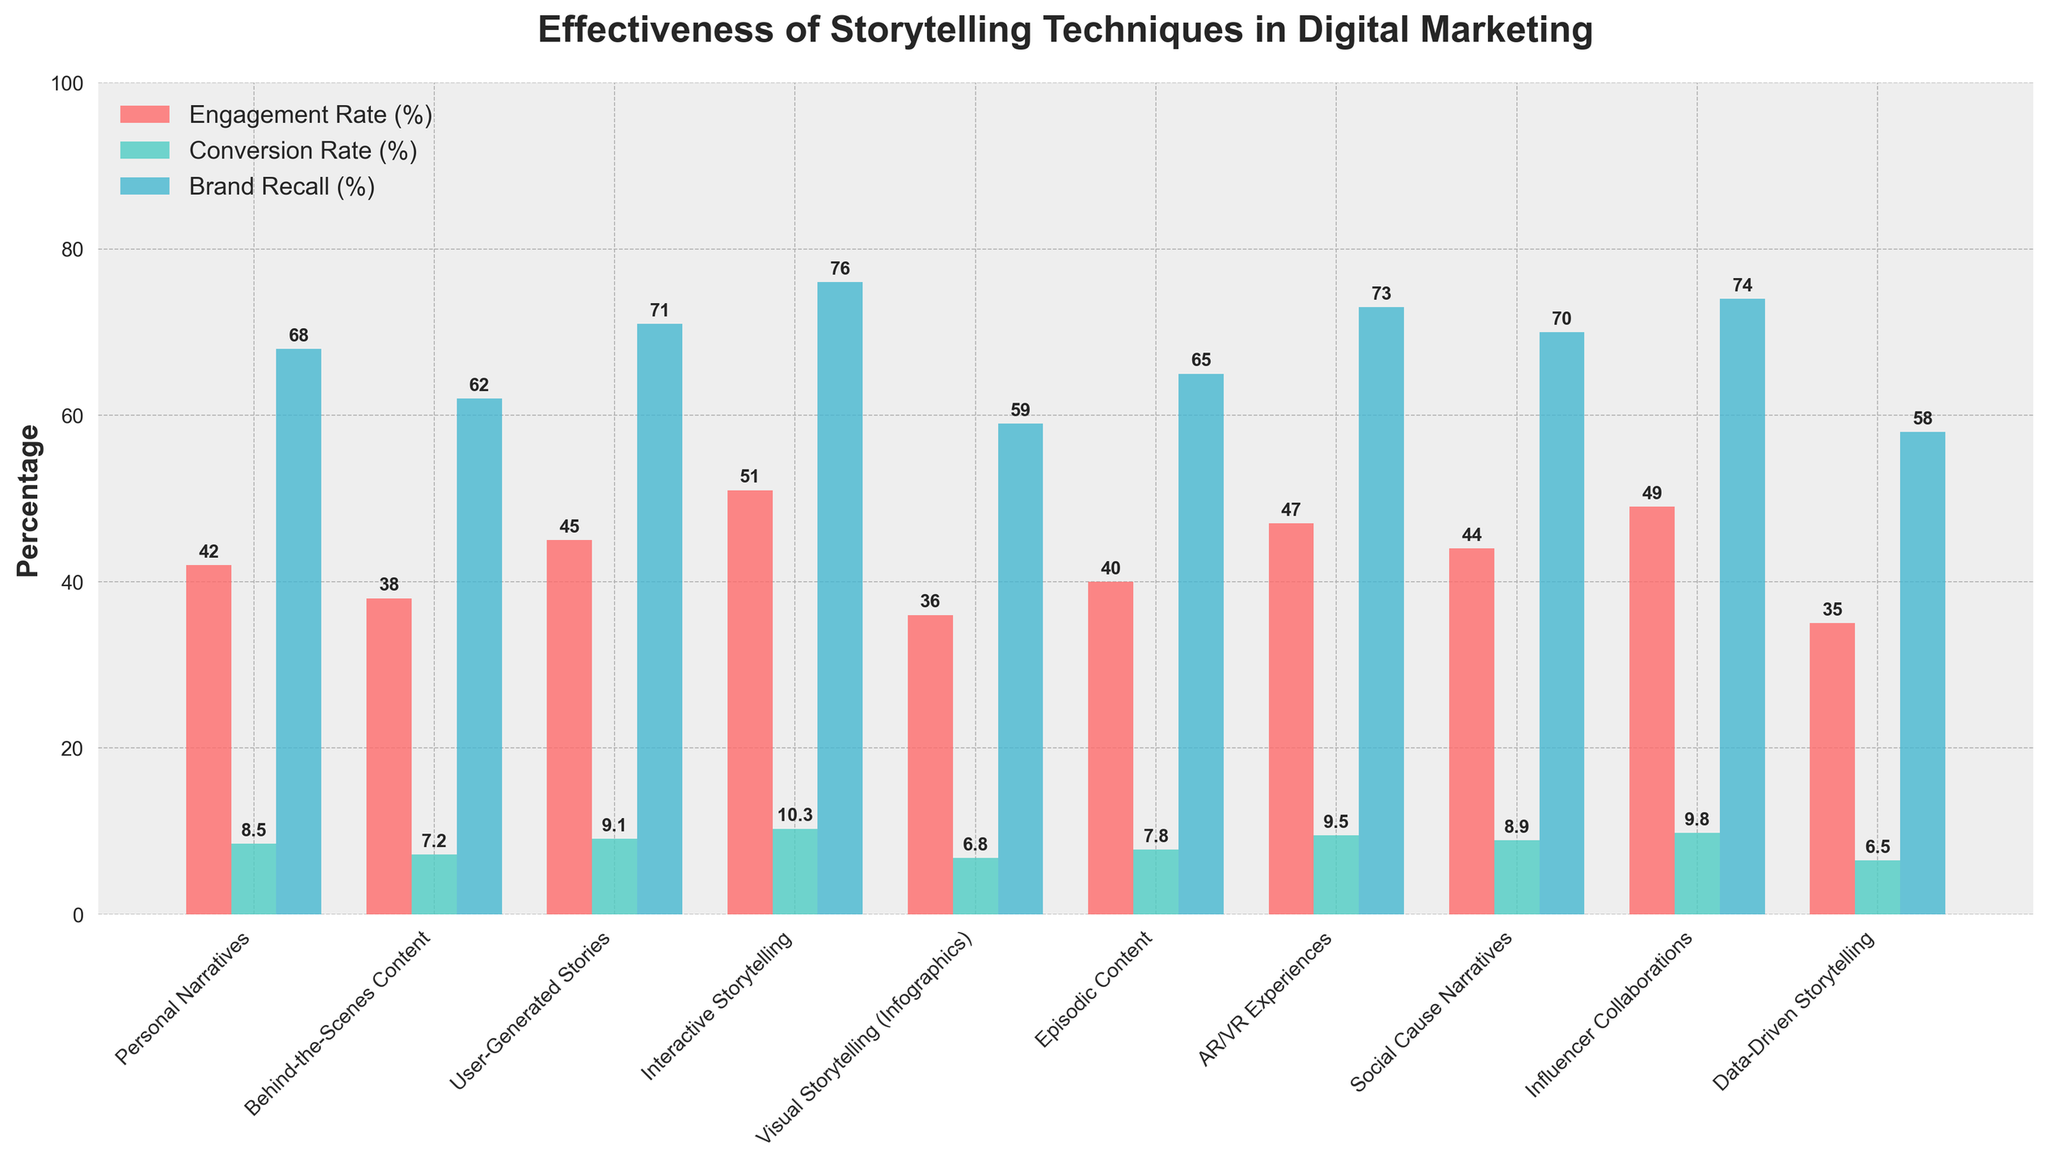How does the engagement rate of "Data-Driven Storytelling" compare to "Interactive Storytelling"? "Data-Driven Storytelling" has an engagement rate of 35%, while "Interactive Storytelling" has an engagement rate of 51%. By comparing these figures, "Interactive Storytelling" has a higher engagement rate than "Data-Driven Storytelling".
Answer: Interactive Storytelling has a higher engagement rate Which storytelling technique has the highest conversion rate? Observing all conversion rate values, "Interactive Storytelling" has the highest conversion rate at 10.3%.
Answer: Interactive Storytelling What is the average brand recall percentage across all storytelling techniques? Summing up all the brand recall percentages: (68 + 62 + 71 + 76 + 59 + 65 + 73 + 70 + 74 + 58) = 676. Since there are 10 techniques, we calculate the average by dividing the total sum by 10. The average brand recall is 676/10 = 67.6%.
Answer: 67.6% Which storytelling techniques have a brand recall percentage higher than 70%? The techniques with brand recall percentages higher than 70% are "User-Generated Stories" (71%), "Interactive Storytelling" (76%), "AR/VR Experiences" (73%), "Influencer Collaborations" (74%), and "Social Cause Narratives" (70%).
Answer: User-Generated Stories, Interactive Storytelling, AR/VR Experiences, Influencer Collaborations For "AR/VR Experiences", how does the engagement rate compare to the conversion rate? The engagement rate for "AR/VR Experiences" is 47%, and the conversion rate is 9.5%. By comparing these two values, the engagement rate is significantly higher than the conversion rate.
Answer: Engagement rate is higher What is the combined conversion rate of "Personal Narratives" and "Behind-the-Scenes Content"? The conversion rate of "Personal Narratives" is 8.5%, and for "Behind-the-Scenes Content" it is 7.2%. Adding these rates together: 8.5% + 7.2% = 15.7%.
Answer: 15.7% How does the brand recall of "Visual Storytelling (Infographics)" compare to the brand recall of "Data-Driven Storytelling"? The brand recall for "Visual Storytelling (Infographics)" is 59%, while for "Data-Driven Storytelling" it is 58%. By comparing these figures, "Visual Storytelling (Infographics)" has a slightly higher brand recall.
Answer: Visual Storytelling (Infographics) has a slightly higher brand recall What is the difference in conversion rate between "Influencer Collaborations" and "Episodic Content"? The conversion rate for "Influencer Collaborations" is 9.8%, and for "Episodic Content" it is 7.8%. The difference is calculated as 9.8% - 7.8% = 2%.
Answer: 2% Which storytelling technique has the lowest engagement rate, and what is that rate? The storytelling technique with the lowest engagement rate is "Data-Driven Storytelling" with a rate of 35%.
Answer: Data-Driven Storytelling, 35% What is the cumulative engagement rate of all storytelling techniques? The engagement rates for each technique are: 42, 38, 45, 51, 36, 40, 47, 44, 49, and 35. Summing these values gives a total engagement rate of 427%.
Answer: 427% 